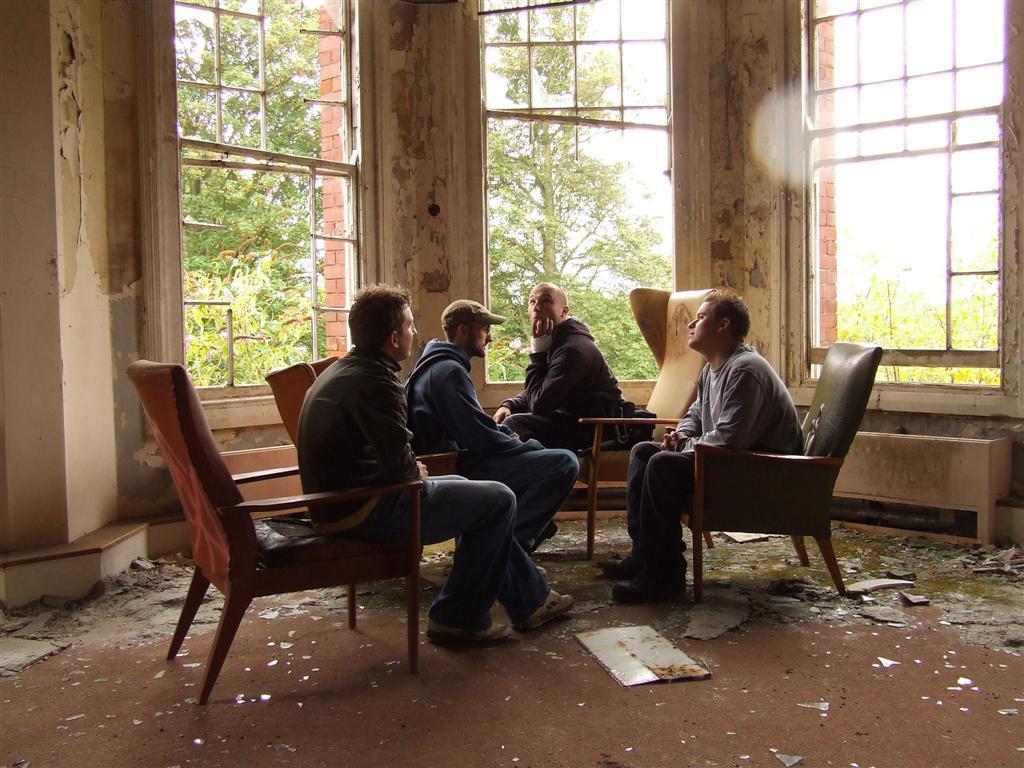Could you give a brief overview of what you see in this image? There are four people sitting in a chair and the ground is dirty and there are windows and trees beside them. 